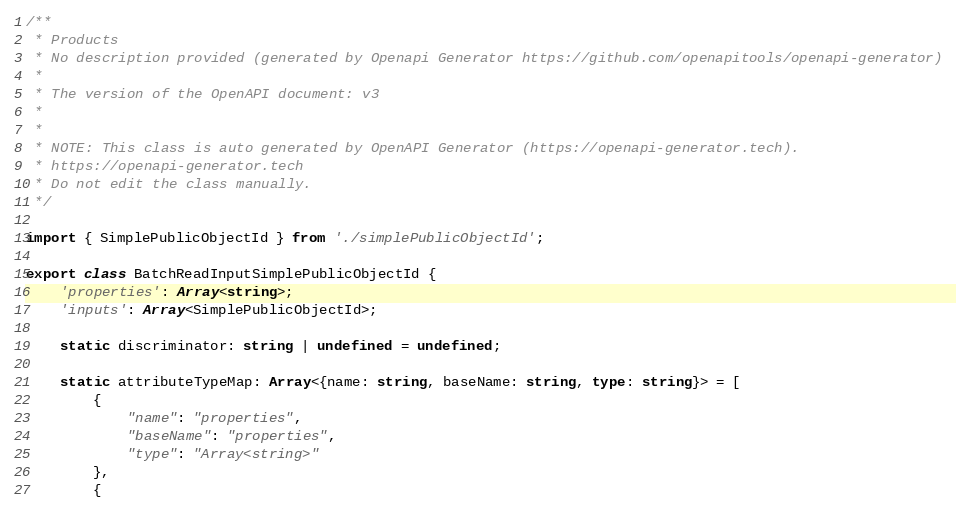<code> <loc_0><loc_0><loc_500><loc_500><_TypeScript_>/**
 * Products
 * No description provided (generated by Openapi Generator https://github.com/openapitools/openapi-generator)
 *
 * The version of the OpenAPI document: v3
 * 
 *
 * NOTE: This class is auto generated by OpenAPI Generator (https://openapi-generator.tech).
 * https://openapi-generator.tech
 * Do not edit the class manually.
 */

import { SimplePublicObjectId } from './simplePublicObjectId';

export class BatchReadInputSimplePublicObjectId {
    'properties': Array<string>;
    'inputs': Array<SimplePublicObjectId>;

    static discriminator: string | undefined = undefined;

    static attributeTypeMap: Array<{name: string, baseName: string, type: string}> = [
        {
            "name": "properties",
            "baseName": "properties",
            "type": "Array<string>"
        },
        {</code> 